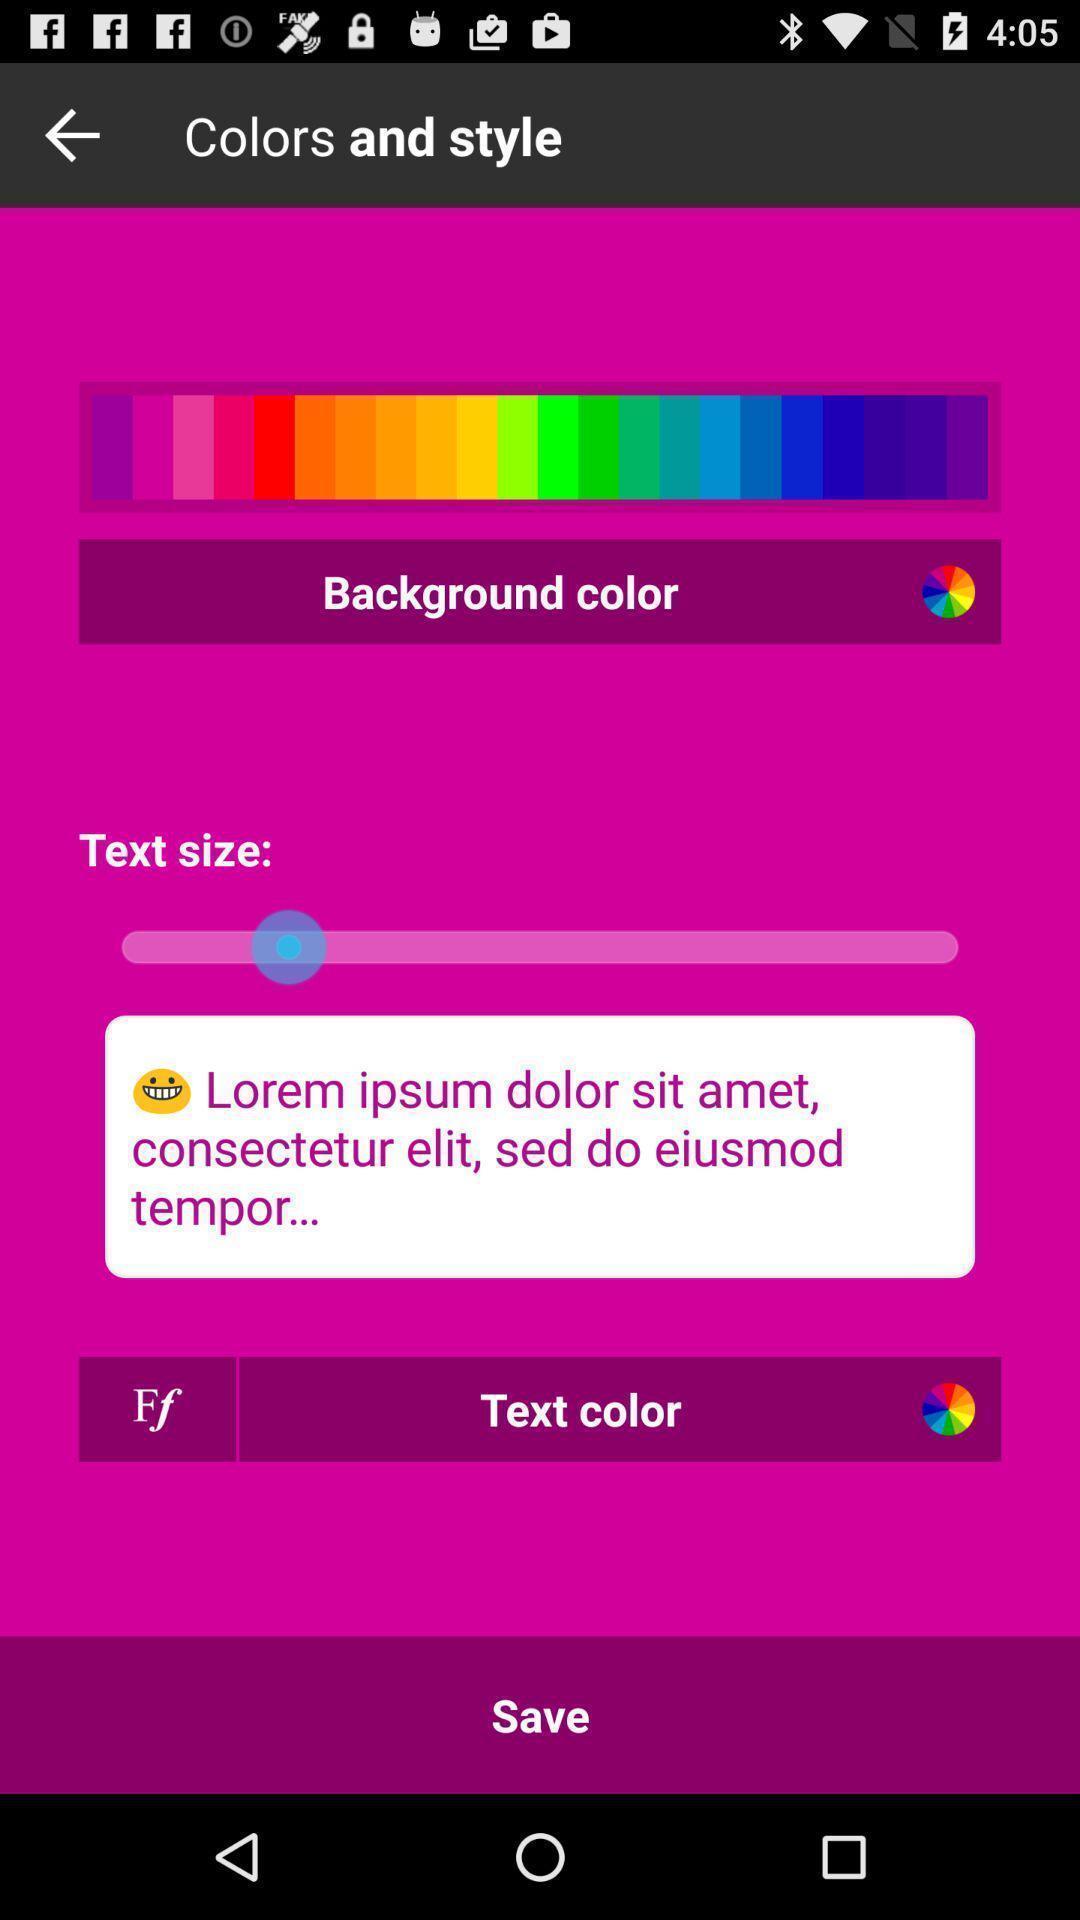Summarize the information in this screenshot. Screen displaying the page of color and text size. 